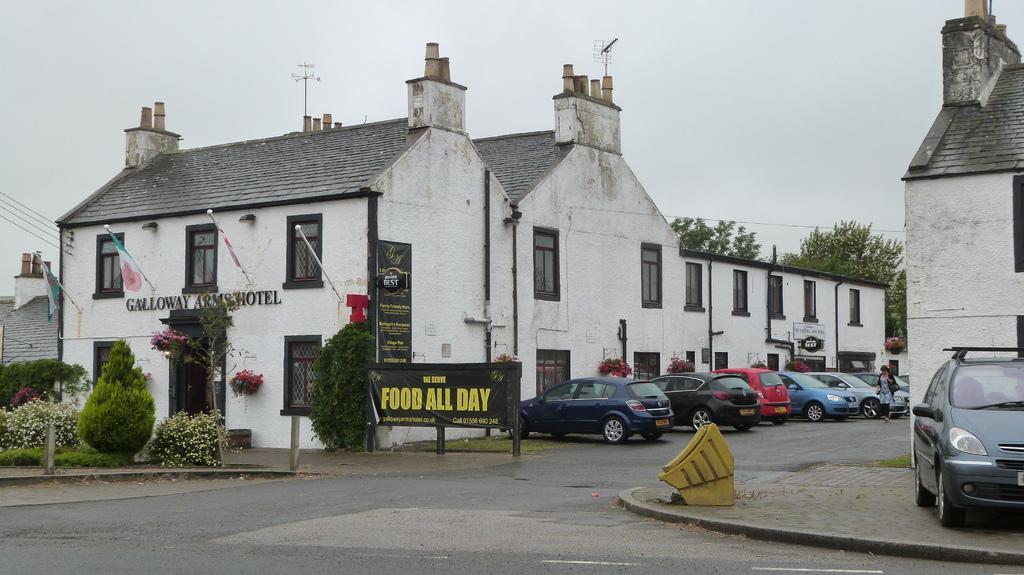Could you give a brief overview of what you see in this image? In this image, I can see the cars, which are parked. Here is the woman walking. These are the buildings with windows. I can see the flags hanging to the poles. These are the plants with flowers. I can see the trees. This looks like a board. I think these are the pipes, which are attached to the building wall. 